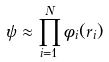<formula> <loc_0><loc_0><loc_500><loc_500>\psi \approx \prod _ { i = 1 } ^ { N } \phi _ { i } ( r _ { i } )</formula> 